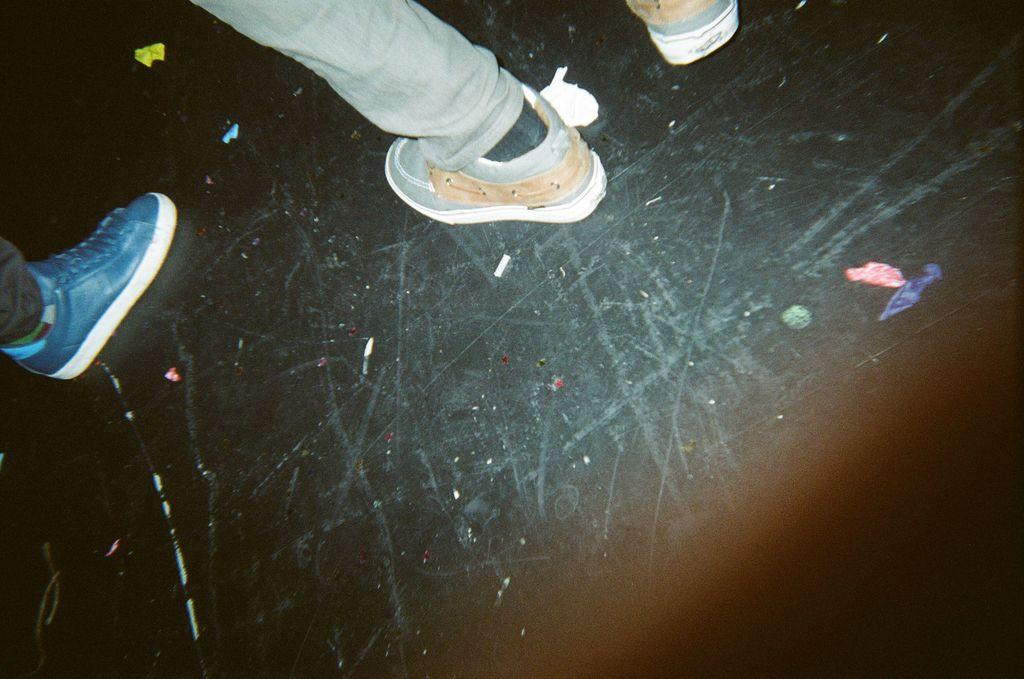What is visible in the image? There are persons' legs visible in the image. Where are the legs located in relation to the floor? The legs are on the floor. How are the legs positioned in the image? The legs are in the center of the image. What type of roll can be seen being prepared by the parent in the image? There is no roll or parent present in the image; it only features legs on the floor. 